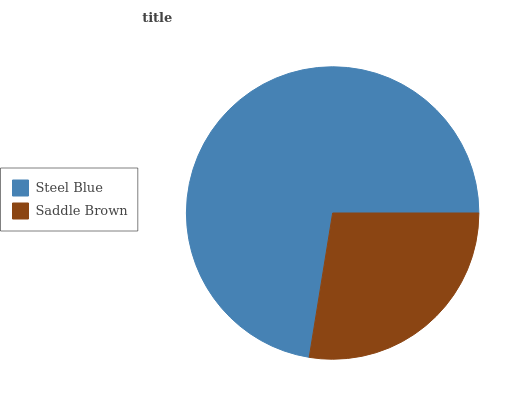Is Saddle Brown the minimum?
Answer yes or no. Yes. Is Steel Blue the maximum?
Answer yes or no. Yes. Is Saddle Brown the maximum?
Answer yes or no. No. Is Steel Blue greater than Saddle Brown?
Answer yes or no. Yes. Is Saddle Brown less than Steel Blue?
Answer yes or no. Yes. Is Saddle Brown greater than Steel Blue?
Answer yes or no. No. Is Steel Blue less than Saddle Brown?
Answer yes or no. No. Is Steel Blue the high median?
Answer yes or no. Yes. Is Saddle Brown the low median?
Answer yes or no. Yes. Is Saddle Brown the high median?
Answer yes or no. No. Is Steel Blue the low median?
Answer yes or no. No. 